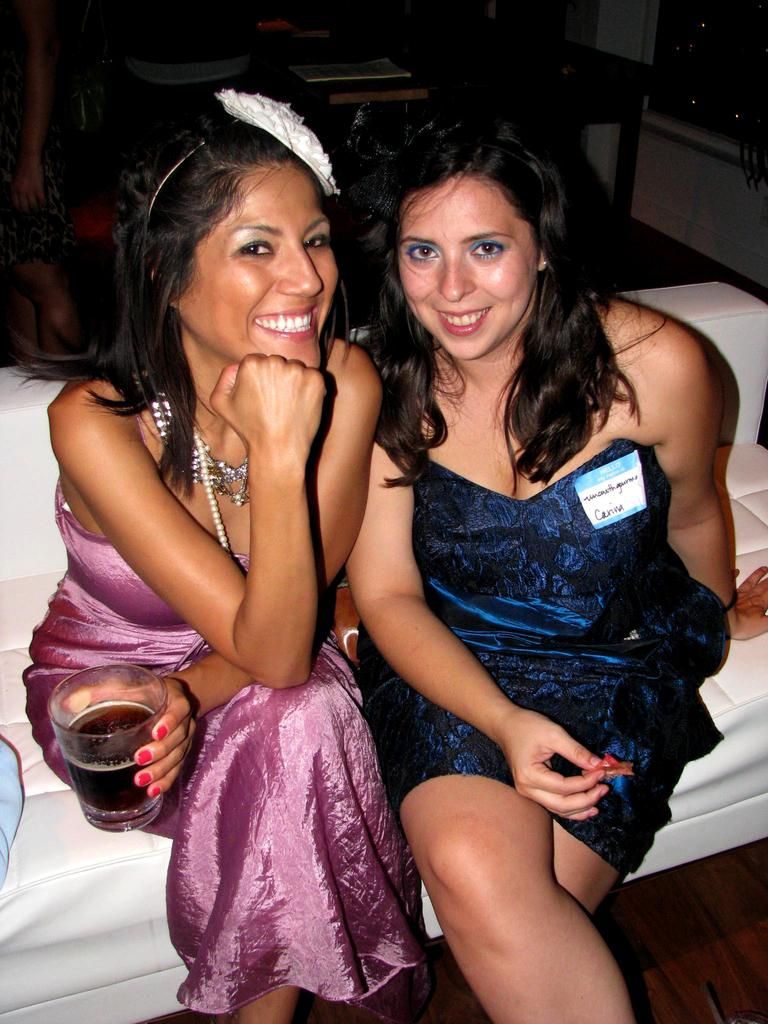What are the ladies in the image doing? The ladies in the image are sitting on the sofa. Can you describe what one of the ladies is holding? One of the ladies is holding a glass with liquid. What can be seen in the background of the image? There is a table visible in the background of the image. What type of discussion is taking place between the ladies about the ocean in the image? There is no discussion about the ocean in the image, nor is there any indication of a discussion taking place. 